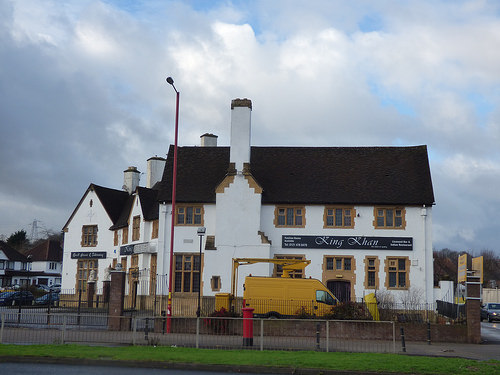<image>
Is there a building next to the grass? No. The building is not positioned next to the grass. They are located in different areas of the scene. 